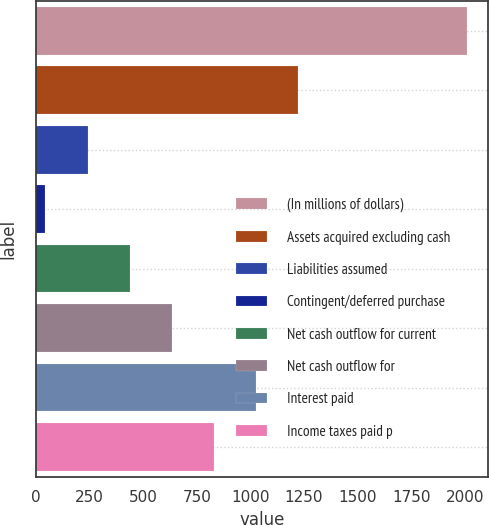Convert chart. <chart><loc_0><loc_0><loc_500><loc_500><bar_chart><fcel>(In millions of dollars)<fcel>Assets acquired excluding cash<fcel>Liabilities assumed<fcel>Contingent/deferred purchase<fcel>Net cash outflow for current<fcel>Net cash outflow for<fcel>Interest paid<fcel>Income taxes paid p<nl><fcel>2008<fcel>1222.8<fcel>241.3<fcel>45<fcel>437.6<fcel>633.9<fcel>1026.5<fcel>830.2<nl></chart> 